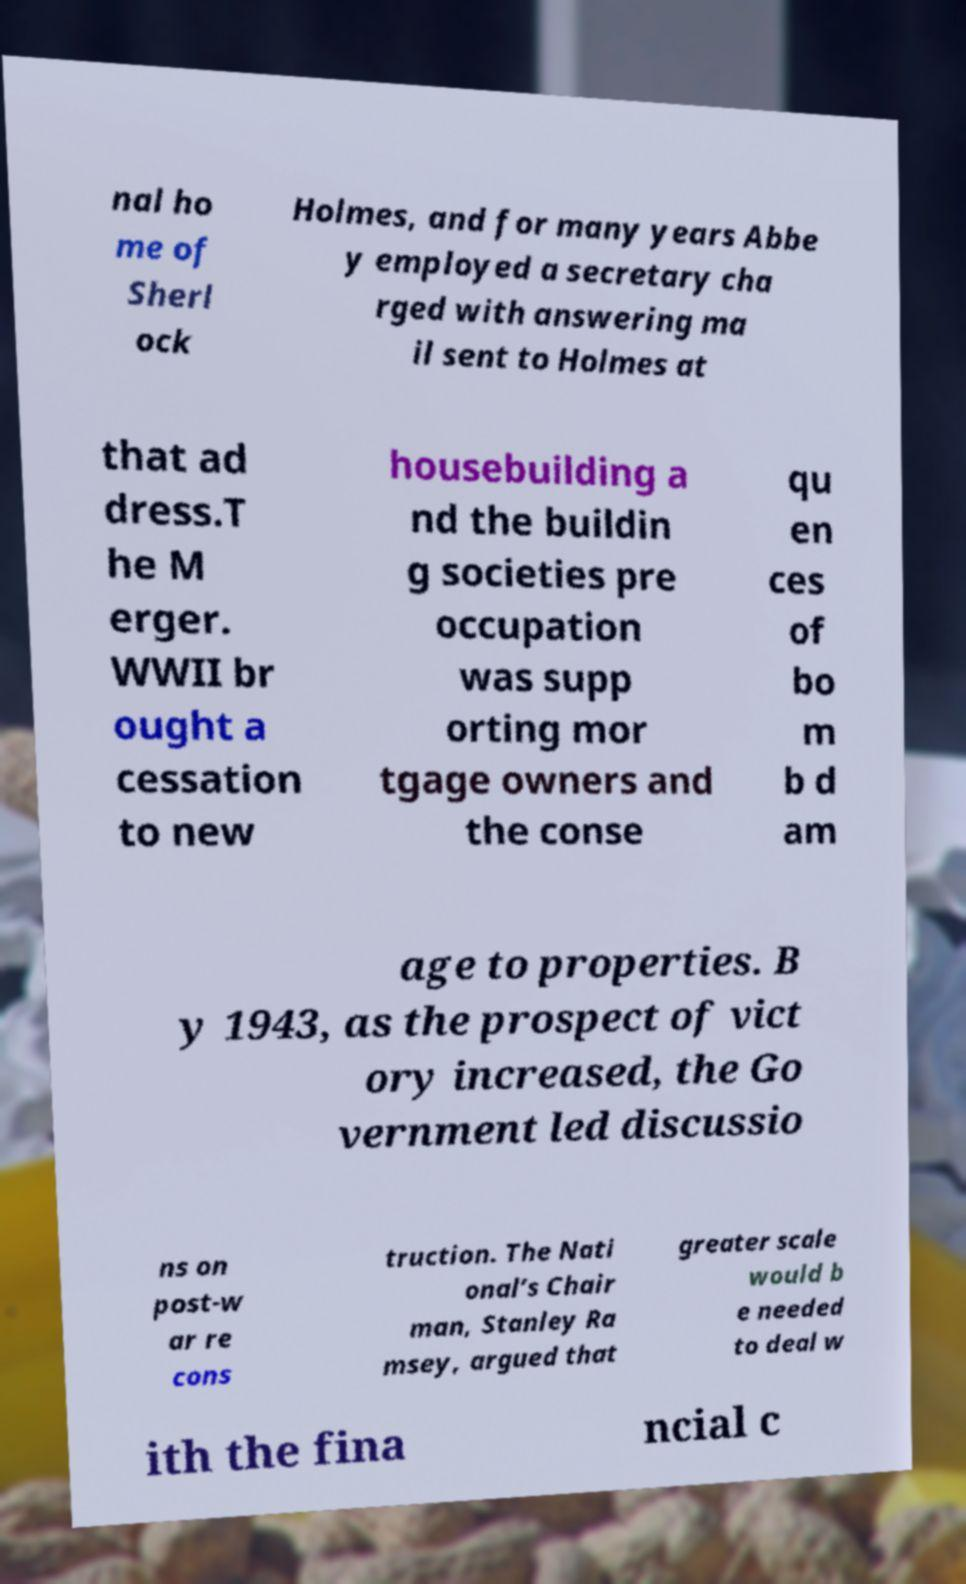Please identify and transcribe the text found in this image. nal ho me of Sherl ock Holmes, and for many years Abbe y employed a secretary cha rged with answering ma il sent to Holmes at that ad dress.T he M erger. WWII br ought a cessation to new housebuilding a nd the buildin g societies pre occupation was supp orting mor tgage owners and the conse qu en ces of bo m b d am age to properties. B y 1943, as the prospect of vict ory increased, the Go vernment led discussio ns on post-w ar re cons truction. The Nati onal’s Chair man, Stanley Ra msey, argued that greater scale would b e needed to deal w ith the fina ncial c 